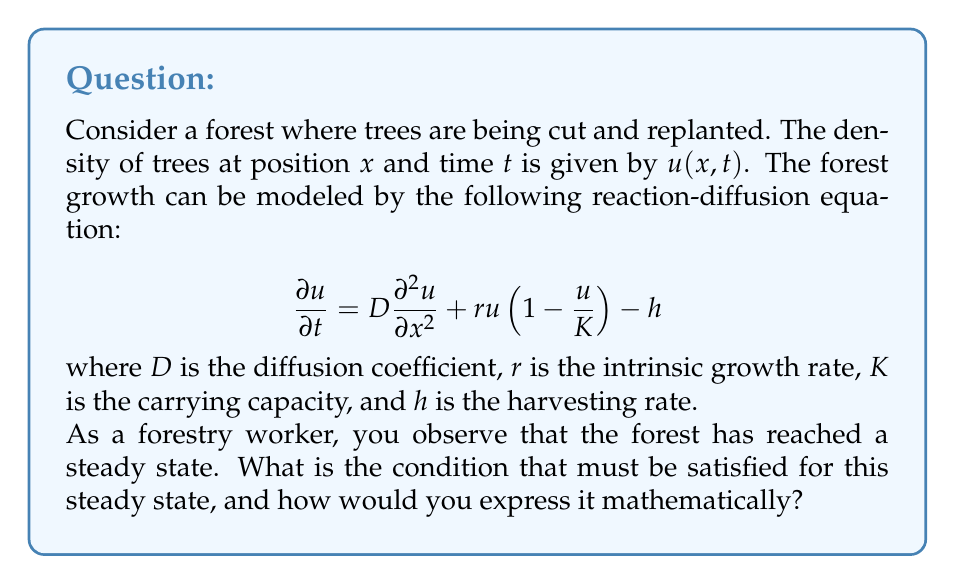Can you answer this question? To solve this problem, we need to understand the concept of steady state in the context of partial differential equations:

1) A steady state implies that the system doesn't change with time. Mathematically, this means $\frac{\partial u}{\partial t} = 0$.

2) Applying this condition to our reaction-diffusion equation:

   $$0 = D\frac{\partial^2 u}{\partial x^2} + ru(1-\frac{u}{K}) - h$$

3) This equation now represents the steady-state condition for our forest model.

4) For a uniform steady state (where tree density doesn't vary with position), we would also have $\frac{\partial^2 u}{\partial x^2} = 0$.

5) Under these conditions, our equation simplifies to:

   $$0 = ru(1-\frac{u}{K}) - h$$

6) This is a quadratic equation in $u$, which can be solved to find the uniform steady-state tree density.

7) The existence of a real, positive solution to this equation would indicate a sustainable balance between growth and harvesting.

Therefore, the mathematical expression for the steady-state condition in this forest model is:

$$D\frac{\partial^2 u}{\partial x^2} + ru(1-\frac{u}{K}) - h = 0$$

This equation must be satisfied at all points $x$ in the forest for the system to be in a steady state.
Answer: The steady-state condition for the forest growth model is:

$$D\frac{\partial^2 u}{\partial x^2} + ru(1-\frac{u}{K}) - h = 0$$ 